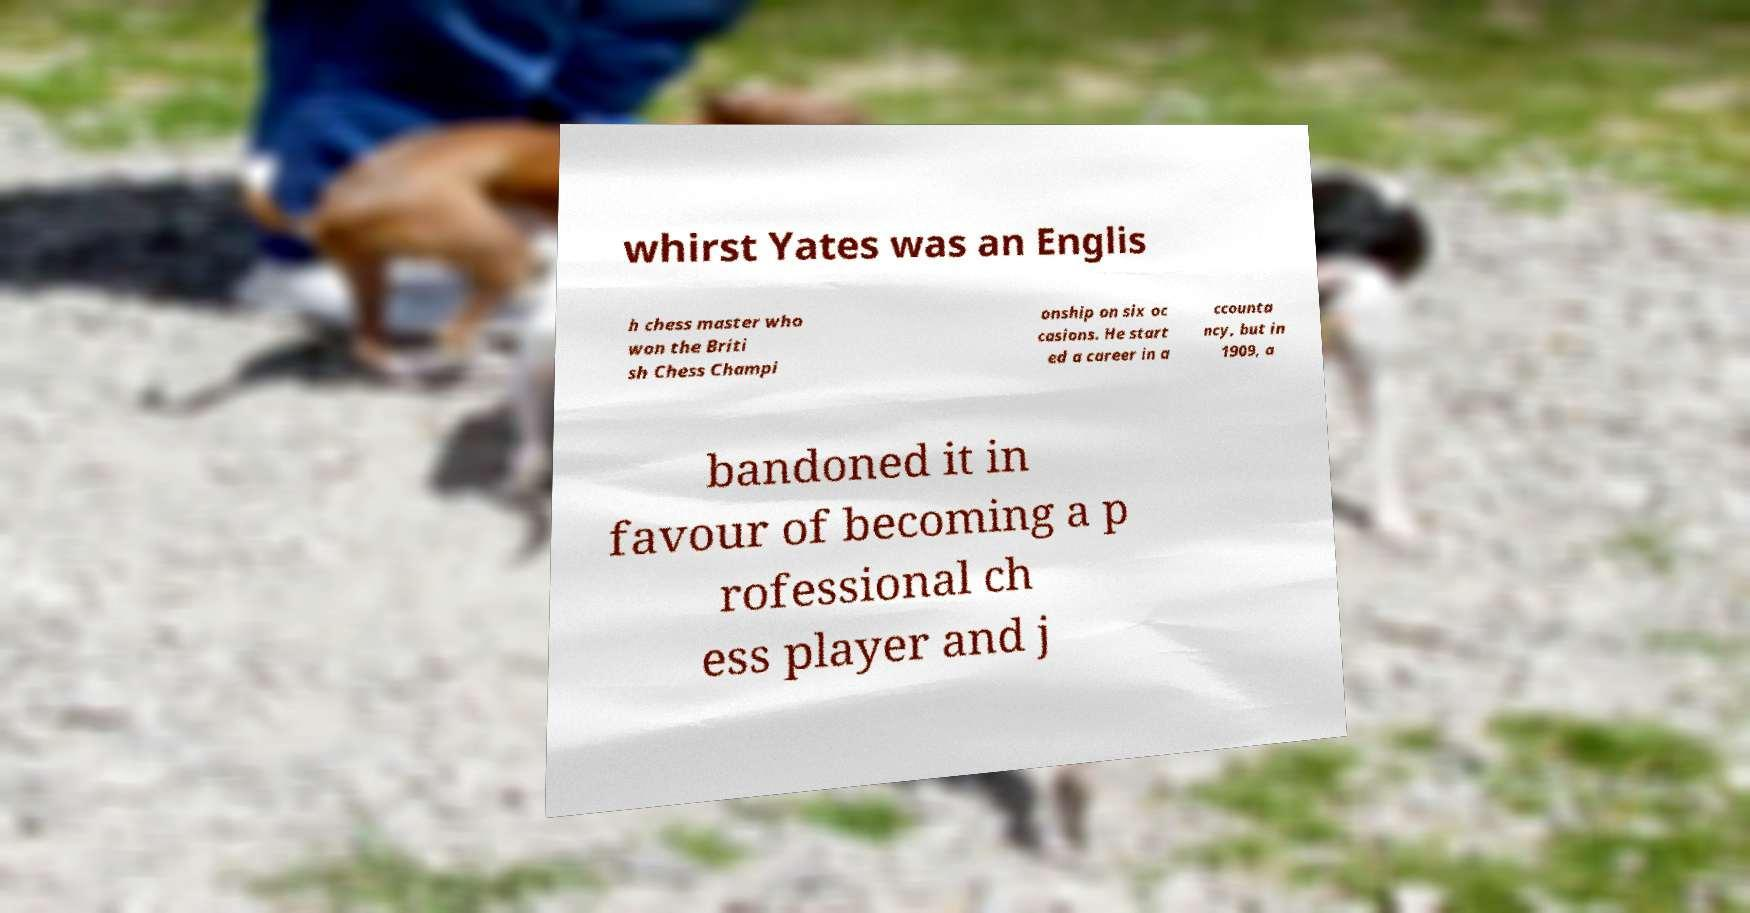Can you accurately transcribe the text from the provided image for me? whirst Yates was an Englis h chess master who won the Briti sh Chess Champi onship on six oc casions. He start ed a career in a ccounta ncy, but in 1909, a bandoned it in favour of becoming a p rofessional ch ess player and j 